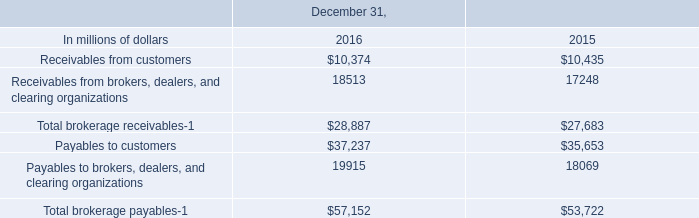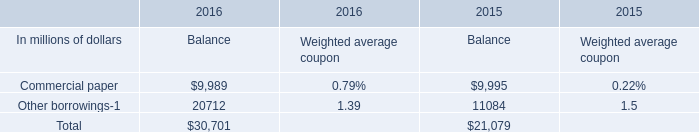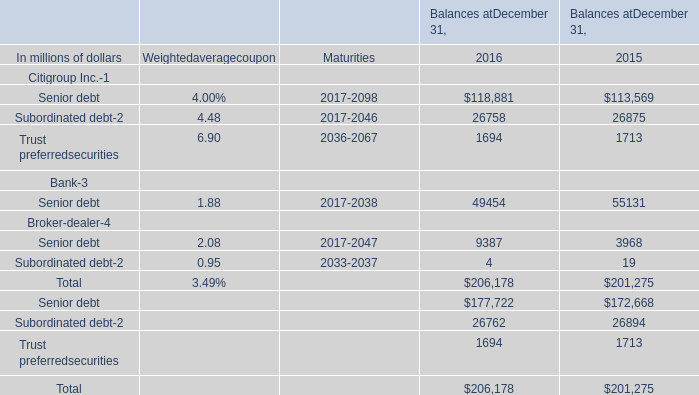Which year is Senior debt for Citigroup Inc. than 118000 ? 
Answer: 2016. 